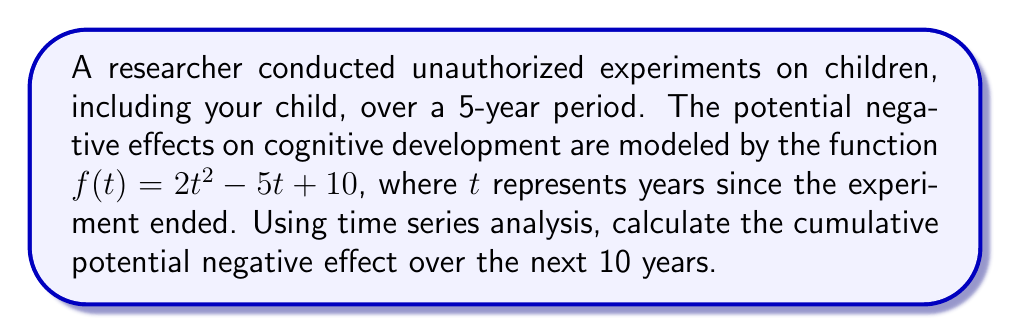What is the answer to this math problem? To solve this problem, we need to follow these steps:

1) The function $f(t) = 2t^2 - 5t + 10$ represents the potential negative effect at time $t$.

2) To find the cumulative effect over 10 years, we need to calculate the definite integral of this function from $t=0$ to $t=10$.

3) The indefinite integral of $f(t)$ is:

   $$F(t) = \int f(t) dt = \int (2t^2 - 5t + 10) dt = \frac{2t^3}{3} - \frac{5t^2}{2} + 10t + C$$

4) Now, we can calculate the definite integral:

   $$\int_0^{10} f(t) dt = F(10) - F(0)$$

5) Let's calculate $F(10)$ and $F(0)$:

   $F(10) = \frac{2(10^3)}{3} - \frac{5(10^2)}{2} + 10(10) = \frac{2000}{3} - 250 + 100$
   
   $F(0) = 0$

6) Therefore, the cumulative effect is:

   $$F(10) - F(0) = (\frac{2000}{3} - 250 + 100) - 0 = \frac{2000}{3} - 150 = \frac{1550}{3} \approx 516.67$$
Answer: $\frac{1550}{3}$ or approximately 516.67 